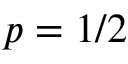<formula> <loc_0><loc_0><loc_500><loc_500>p = 1 / 2</formula> 